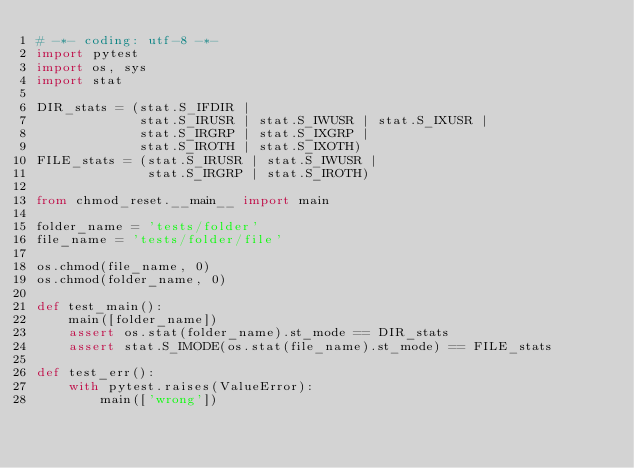<code> <loc_0><loc_0><loc_500><loc_500><_Python_># -*- coding: utf-8 -*-
import pytest
import os, sys
import stat

DIR_stats = (stat.S_IFDIR |
             stat.S_IRUSR | stat.S_IWUSR | stat.S_IXUSR |
             stat.S_IRGRP | stat.S_IXGRP |
             stat.S_IROTH | stat.S_IXOTH)
FILE_stats = (stat.S_IRUSR | stat.S_IWUSR |
              stat.S_IRGRP | stat.S_IROTH)

from chmod_reset.__main__ import main

folder_name = 'tests/folder'
file_name = 'tests/folder/file'

os.chmod(file_name, 0)
os.chmod(folder_name, 0)

def test_main():
    main([folder_name])
    assert os.stat(folder_name).st_mode == DIR_stats
    assert stat.S_IMODE(os.stat(file_name).st_mode) == FILE_stats

def test_err():
    with pytest.raises(ValueError):
        main(['wrong'])
</code> 